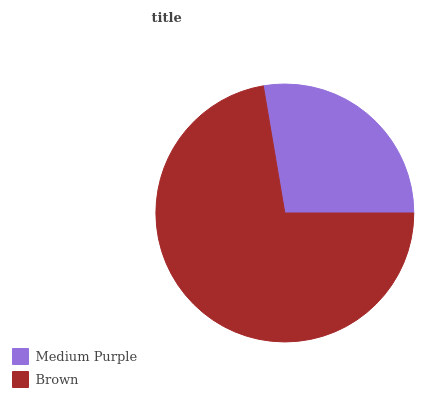Is Medium Purple the minimum?
Answer yes or no. Yes. Is Brown the maximum?
Answer yes or no. Yes. Is Brown the minimum?
Answer yes or no. No. Is Brown greater than Medium Purple?
Answer yes or no. Yes. Is Medium Purple less than Brown?
Answer yes or no. Yes. Is Medium Purple greater than Brown?
Answer yes or no. No. Is Brown less than Medium Purple?
Answer yes or no. No. Is Brown the high median?
Answer yes or no. Yes. Is Medium Purple the low median?
Answer yes or no. Yes. Is Medium Purple the high median?
Answer yes or no. No. Is Brown the low median?
Answer yes or no. No. 